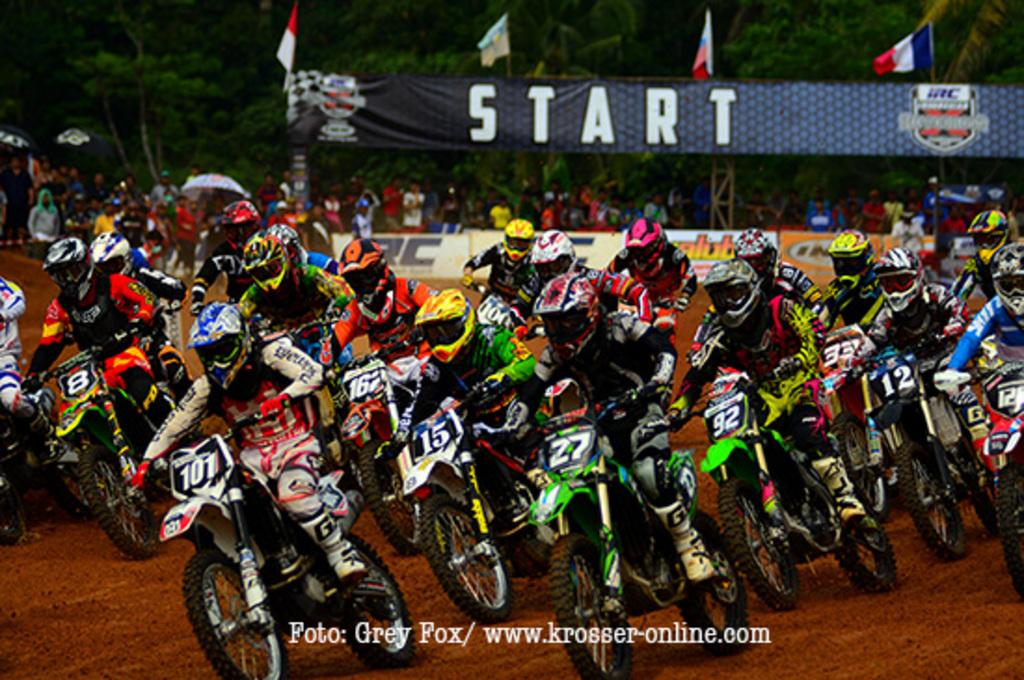What are the people in the image doing? The people in the image are riding bikes. What are the people wearing while riding bikes? The people are wearing helmets. Where are the people riding bikes located? The people are in front of trees. What additional items can be seen in the image related to the event? There is a banner and flags in the image. What type of lunch is being served in the image? There is no lunch being served in the image; it features a group of people riding bikes. How does the crow interact with the bikes in the image? There is no crow present in the image; it only features a group of people riding bikes. 